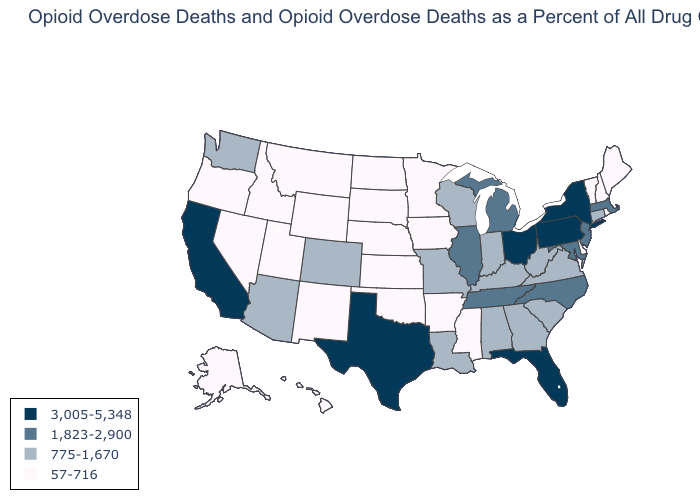Name the states that have a value in the range 3,005-5,348?
Be succinct. California, Florida, New York, Ohio, Pennsylvania, Texas. Is the legend a continuous bar?
Concise answer only. No. What is the value of Massachusetts?
Write a very short answer. 1,823-2,900. What is the value of Florida?
Answer briefly. 3,005-5,348. Does Arizona have the lowest value in the West?
Write a very short answer. No. Among the states that border Arizona , which have the highest value?
Quick response, please. California. Among the states that border Colorado , does Arizona have the lowest value?
Give a very brief answer. No. Name the states that have a value in the range 1,823-2,900?
Concise answer only. Illinois, Maryland, Massachusetts, Michigan, New Jersey, North Carolina, Tennessee. Name the states that have a value in the range 3,005-5,348?
Quick response, please. California, Florida, New York, Ohio, Pennsylvania, Texas. What is the value of Kansas?
Be succinct. 57-716. Name the states that have a value in the range 775-1,670?
Answer briefly. Alabama, Arizona, Colorado, Connecticut, Georgia, Indiana, Kentucky, Louisiana, Missouri, South Carolina, Virginia, Washington, West Virginia, Wisconsin. What is the lowest value in states that border Virginia?
Write a very short answer. 775-1,670. How many symbols are there in the legend?
Be succinct. 4. Does Alaska have the lowest value in the West?
Write a very short answer. Yes. What is the value of Washington?
Answer briefly. 775-1,670. 